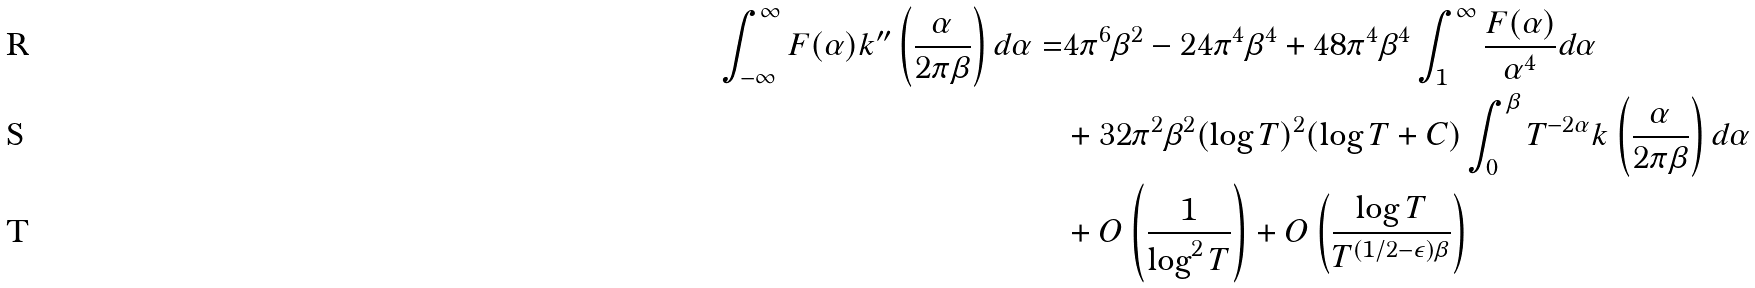Convert formula to latex. <formula><loc_0><loc_0><loc_500><loc_500>\int _ { - \infty } ^ { \infty } F ( \alpha ) k ^ { \prime \prime } \left ( \frac { \alpha } { 2 \pi \beta } \right ) d \alpha = & 4 \pi ^ { 6 } \beta ^ { 2 } - 2 4 \pi ^ { 4 } \beta ^ { 4 } + 4 8 \pi ^ { 4 } \beta ^ { 4 } \int _ { 1 } ^ { \infty } \frac { F ( \alpha ) } { \alpha ^ { 4 } } d \alpha \\ & + 3 2 \pi ^ { 2 } \beta ^ { 2 } ( \log { T } ) ^ { 2 } ( \log { T } + C ) \int _ { 0 } ^ { \beta } T ^ { - 2 \alpha } k \left ( \frac { \alpha } { 2 \pi \beta } \right ) d \alpha \\ & + O \left ( \frac { 1 } { \log ^ { 2 } { T } } \right ) + O \left ( \frac { \log { T } } { T ^ { ( 1 / 2 - \epsilon ) \beta } } \right )</formula> 